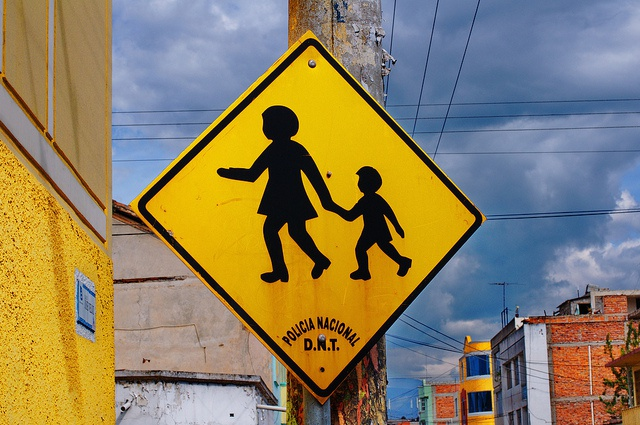Describe the objects in this image and their specific colors. I can see various objects in this image with different colors. 